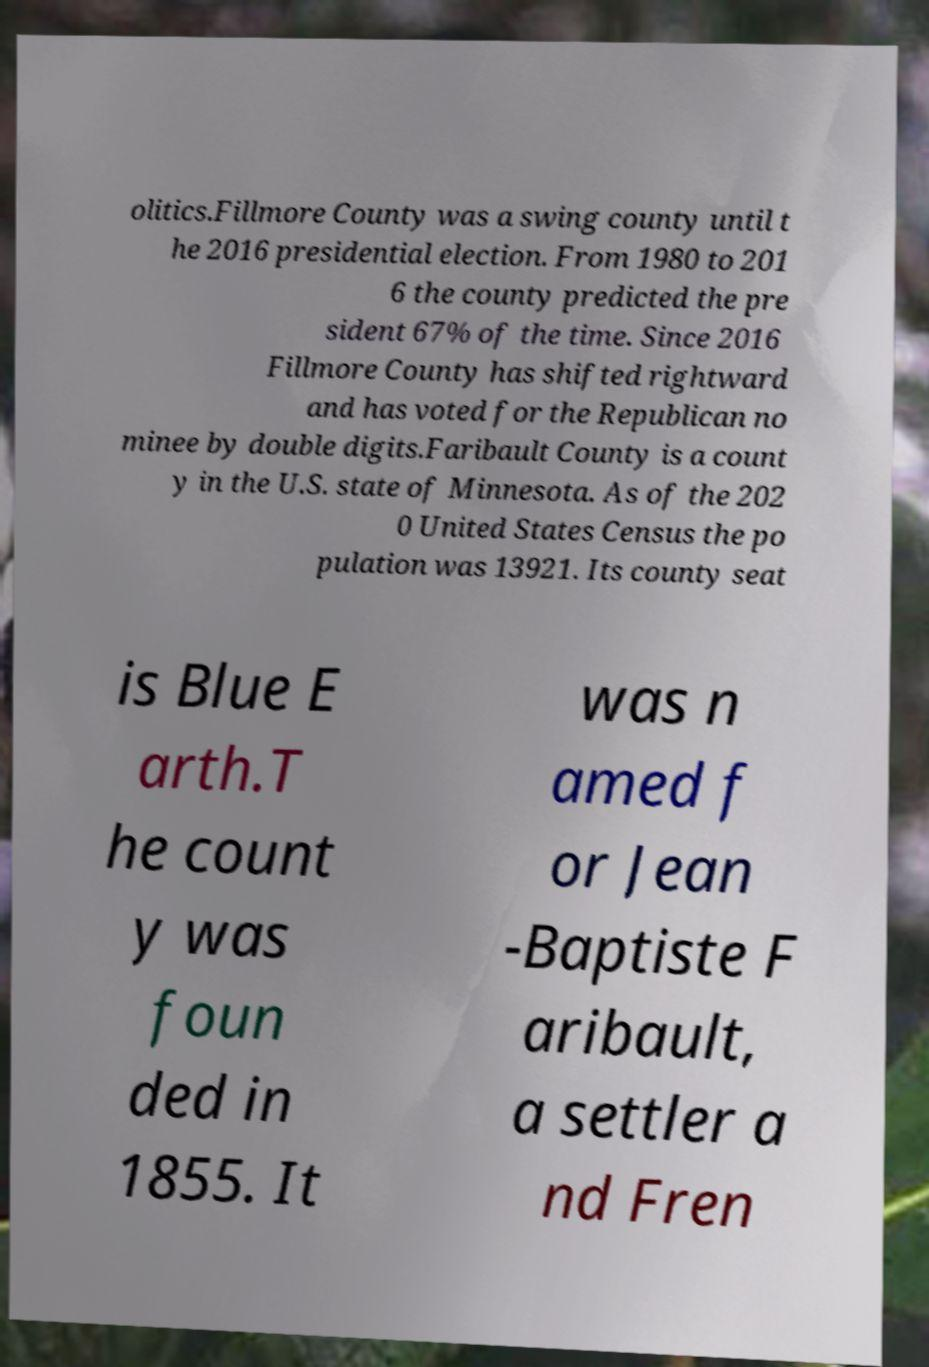Could you extract and type out the text from this image? olitics.Fillmore County was a swing county until t he 2016 presidential election. From 1980 to 201 6 the county predicted the pre sident 67% of the time. Since 2016 Fillmore County has shifted rightward and has voted for the Republican no minee by double digits.Faribault County is a count y in the U.S. state of Minnesota. As of the 202 0 United States Census the po pulation was 13921. Its county seat is Blue E arth.T he count y was foun ded in 1855. It was n amed f or Jean -Baptiste F aribault, a settler a nd Fren 